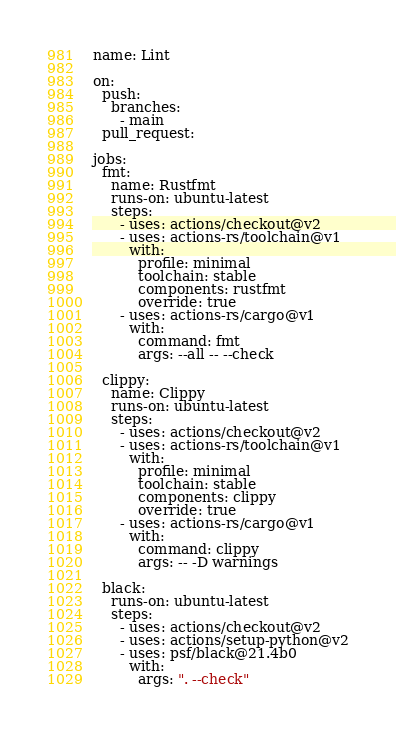<code> <loc_0><loc_0><loc_500><loc_500><_YAML_>name: Lint

on:
  push:
    branches:
      - main
  pull_request:

jobs:
  fmt:
    name: Rustfmt
    runs-on: ubuntu-latest
    steps:
      - uses: actions/checkout@v2
      - uses: actions-rs/toolchain@v1
        with:
          profile: minimal
          toolchain: stable
          components: rustfmt
          override: true
      - uses: actions-rs/cargo@v1
        with:
          command: fmt
          args: --all -- --check

  clippy:
    name: Clippy
    runs-on: ubuntu-latest
    steps:
      - uses: actions/checkout@v2
      - uses: actions-rs/toolchain@v1
        with:
          profile: minimal
          toolchain: stable
          components: clippy
          override: true
      - uses: actions-rs/cargo@v1
        with:
          command: clippy
          args: -- -D warnings

  black:
    runs-on: ubuntu-latest
    steps:
      - uses: actions/checkout@v2
      - uses: actions/setup-python@v2
      - uses: psf/black@21.4b0
        with:
          args: ". --check"</code> 